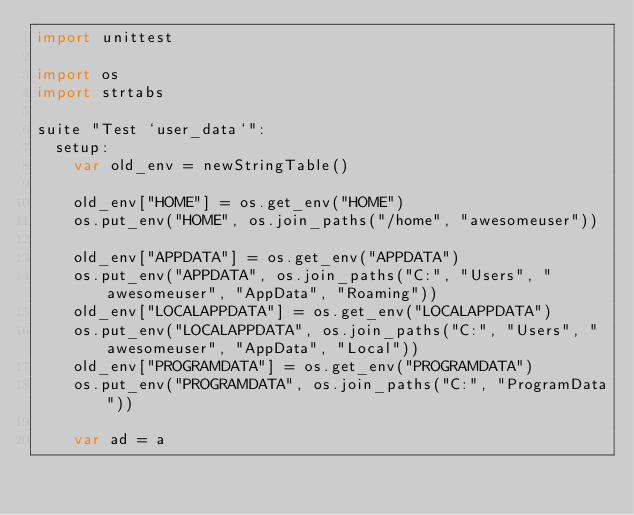<code> <loc_0><loc_0><loc_500><loc_500><_Nim_>import unittest

import os
import strtabs

suite "Test `user_data`":
  setup:
    var old_env = newStringTable()

    old_env["HOME"] = os.get_env("HOME")
    os.put_env("HOME", os.join_paths("/home", "awesomeuser"))

    old_env["APPDATA"] = os.get_env("APPDATA")
    os.put_env("APPDATA", os.join_paths("C:", "Users", "awesomeuser", "AppData", "Roaming"))
    old_env["LOCALAPPDATA"] = os.get_env("LOCALAPPDATA")
    os.put_env("LOCALAPPDATA", os.join_paths("C:", "Users", "awesomeuser", "AppData", "Local"))
    old_env["PROGRAMDATA"] = os.get_env("PROGRAMDATA")
    os.put_env("PROGRAMDATA", os.join_paths("C:", "ProgramData"))

    var ad = a</code> 